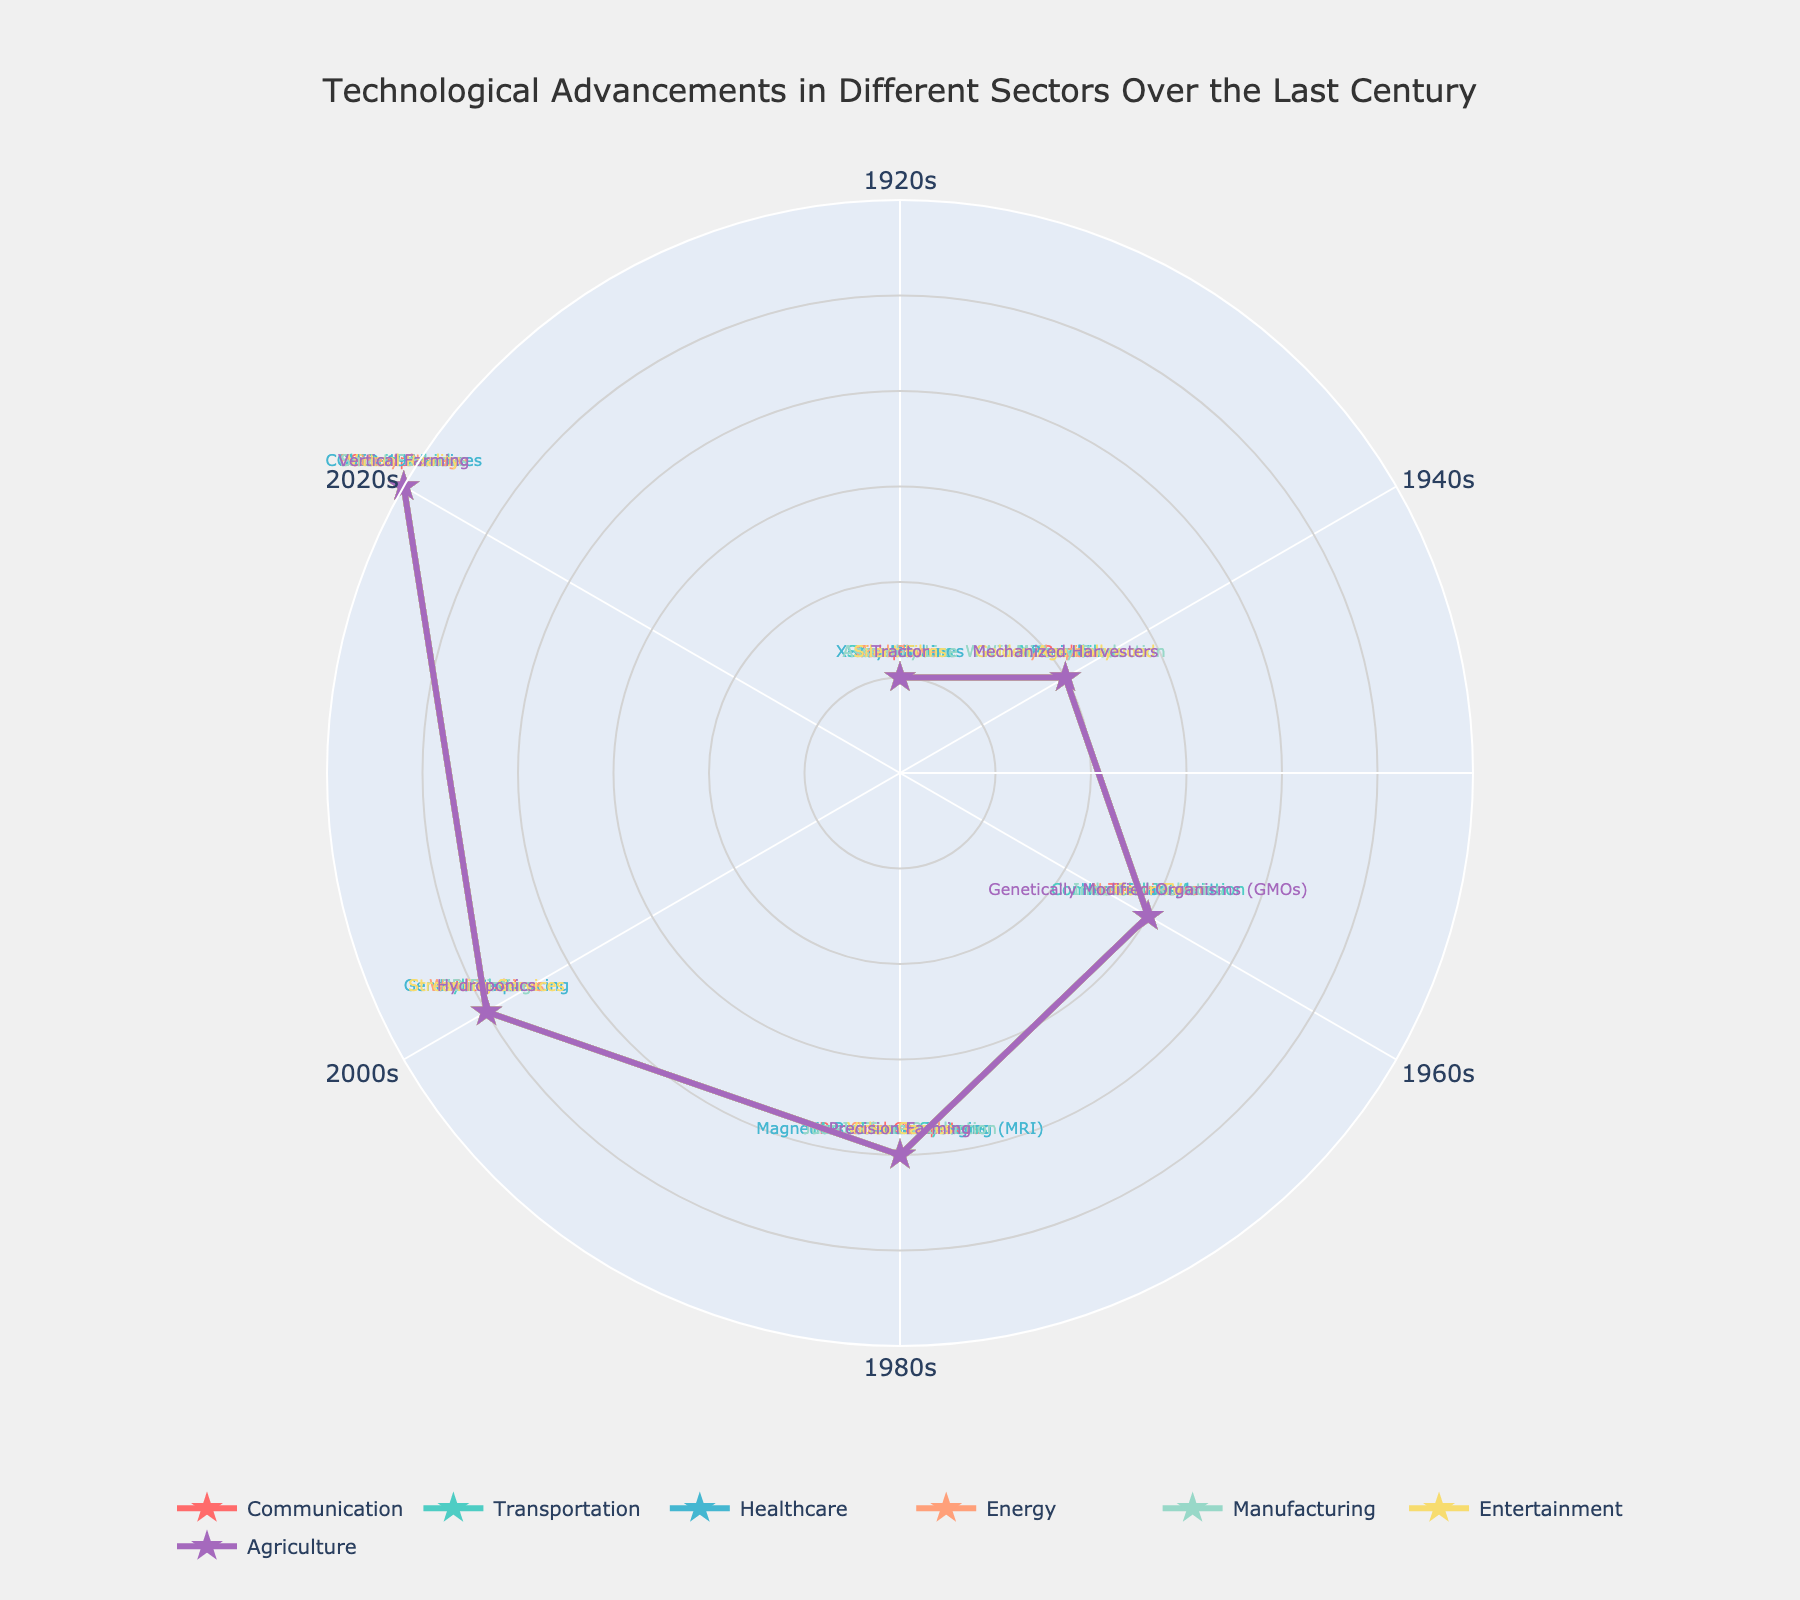Which sector has "COVID-19 Vaccines" as one of its technological advancements? The polar chart shows that "COVID-19 Vaccines" appear in the sector labeled Healthcare for the 2020s decade.
Answer: Healthcare Which decade features "Commercial Jet Aviation" in transportation? Referring to the polar chart, "Commercial Jet Aviation" is found in the 1960s decade within the transportation sector.
Answer: 1960s What technological advancement in the communication sector is shown for the 1980s? The polar chart lists "Personal Computers" for the 1980s in the communication sector.
Answer: Personal Computers How many sectors have technological advancements listed for the 1940s? By counting the sectors with advancements in the 1940s radial axis, we find that there are seven sectors with advancements.
Answer: 7 Which sector utilizes "Virtual Reality" and in which decade does it appear? Referring to the labels around the polar chart, "Virtual Reality" appears in the 2020s for the entertainment sector.
Answer: Entertainment, 2020s Compare the healthcare advancements of the 1980s and 2000s. Which one is more advanced? "Magnetic Resonance Imaging (MRI)" in the 1980s and "Genome Sequencing" in the 2000s suggest greater progressive technological sophistication in the 2000s in Healthcare.
Answer: 2000s What is the difference in technological advancements between the 1920s and 2020s in the agriculture sector? The 1920s show the technology "Tractor" while the 2020s feature "Vertical Farming", indicating significant technological progression.
Answer: Vertical Farming - Tractor Identify the decade where both entertainment and manufacturing sectors show significant technological advancements. Observing the polar chart, both sectors show “Color TV” and “Industrial Robotics” which are significant technological advancements during the 1960s.
Answer: 1960s What pattern do you observe in the transportation sector over the last century? The trend in transportation advances from "Steam Trains" to "Electric Vehicles" signifies a shift towards cleaner and more efficient technology over the decades.
Answer: Cleaner and more efficient technology How do the technological advancements in the communication sector progress from the 1920s to the 2020s? Starting with "Telephone" in the 1920s, the communication sector advances through "Radio," "Television," "Personal Computers," "Internet," and finally "Smartphones," reflecting rapid technological progress.
Answer: Rapid technological progress 